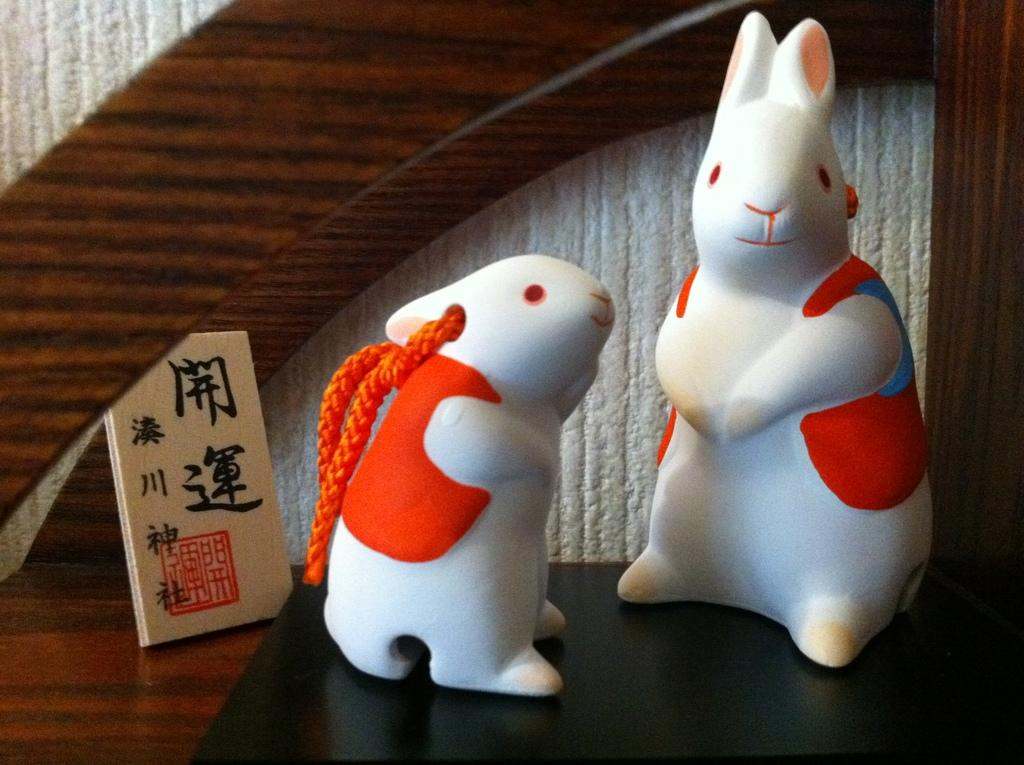What objects can be seen in the image? There are toys in the image. What piece of furniture is present in the image? There is a table in the image. What is on the table in the image? There is a board on the table in the image. Is there an umbrella being used to make a decision in the image? There is no umbrella or decision-making activity depicted in the image. 